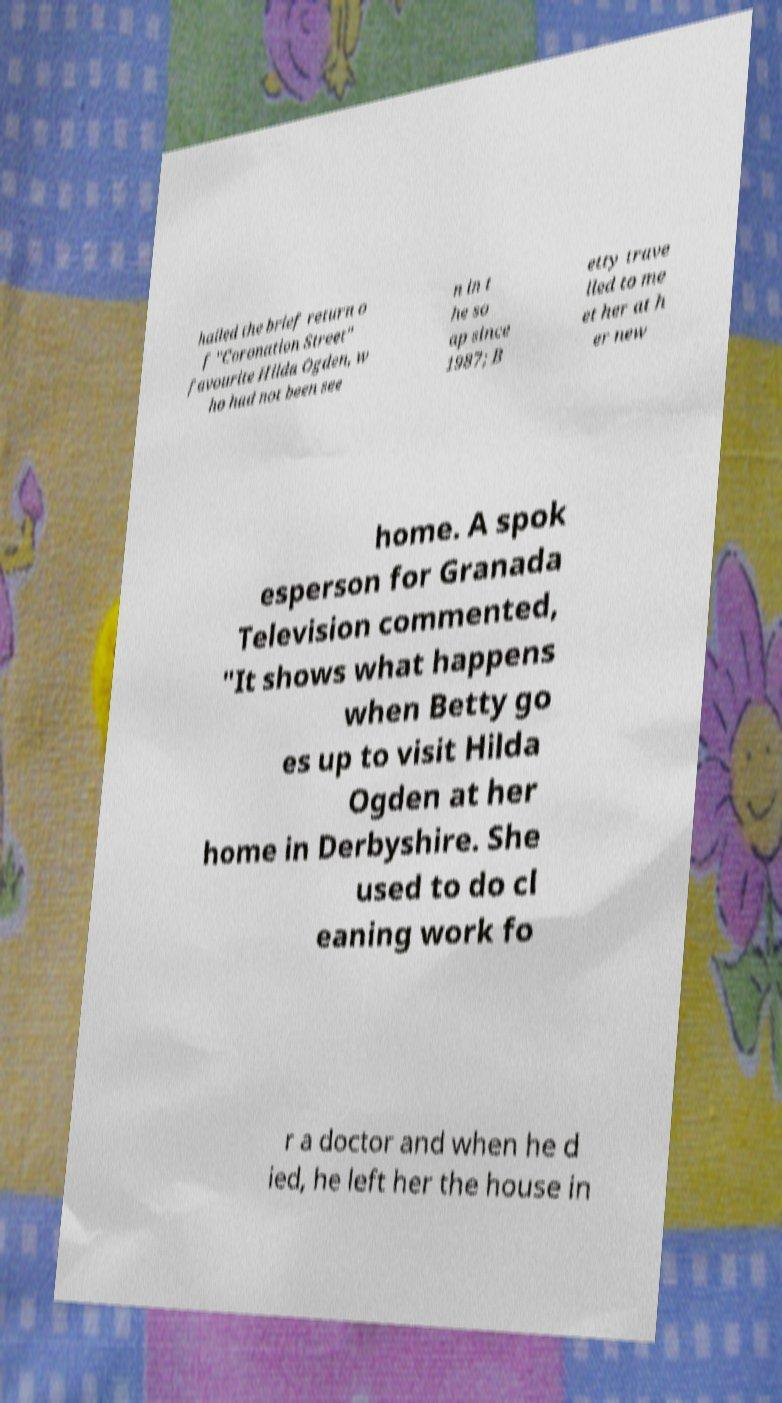Could you assist in decoding the text presented in this image and type it out clearly? hailed the brief return o f "Coronation Street" favourite Hilda Ogden, w ho had not been see n in t he so ap since 1987; B etty trave lled to me et her at h er new home. A spok esperson for Granada Television commented, "It shows what happens when Betty go es up to visit Hilda Ogden at her home in Derbyshire. She used to do cl eaning work fo r a doctor and when he d ied, he left her the house in 